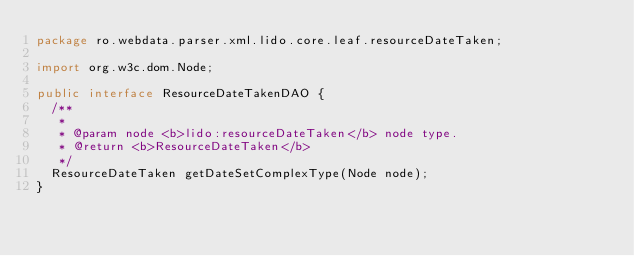<code> <loc_0><loc_0><loc_500><loc_500><_Java_>package ro.webdata.parser.xml.lido.core.leaf.resourceDateTaken;

import org.w3c.dom.Node;

public interface ResourceDateTakenDAO {
	/**
	 *
	 * @param node <b>lido:resourceDateTaken</b> node type.
	 * @return <b>ResourceDateTaken</b>
	 */
	ResourceDateTaken getDateSetComplexType(Node node);
}
</code> 